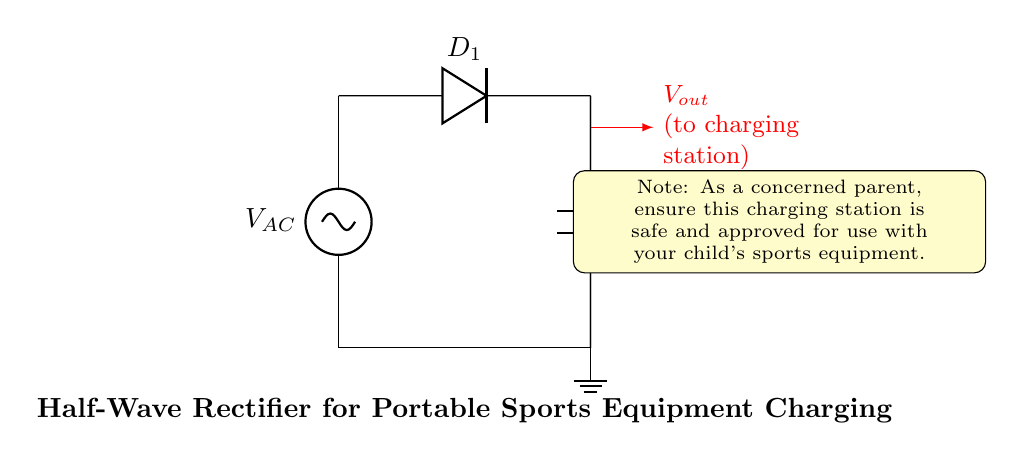What is the power source used in this circuit? The power source in this circuit is labeled as V_AC, which stands for an alternating current voltage source. This is the component that provides the input power to the rectifier.
Answer: V_AC What component is used to convert AC to DC? The diode labeled D_1 is the component that allows current to flow in only one direction, effectively converting alternating current (AC) into direct current (DC) by blocking the reverse flow.
Answer: D_1 What is the load component in this circuit? The load component in the circuit is represented by R_L, indicating a resistor that represents the load on the circuit that will utilize the rectified voltage.
Answer: R_L What component smooths the output voltage? The capacitor labeled C_1 is used to smooth the output voltage by reducing fluctuations and providing a more stable DC output after rectification.
Answer: C_1 How many diodes are present in this half-wave rectifier? There is only one diode in this half-wave rectifier circuit, as indicated by the presence of D_1 in the diagram. The half-wave rectifier only requires one diode to function.
Answer: 1 What type of rectification does this circuit perform? This circuit is performing half-wave rectification, characterized by using a single diode to only allow one half of the AC waveform to pass through to the load.
Answer: Half-wave 